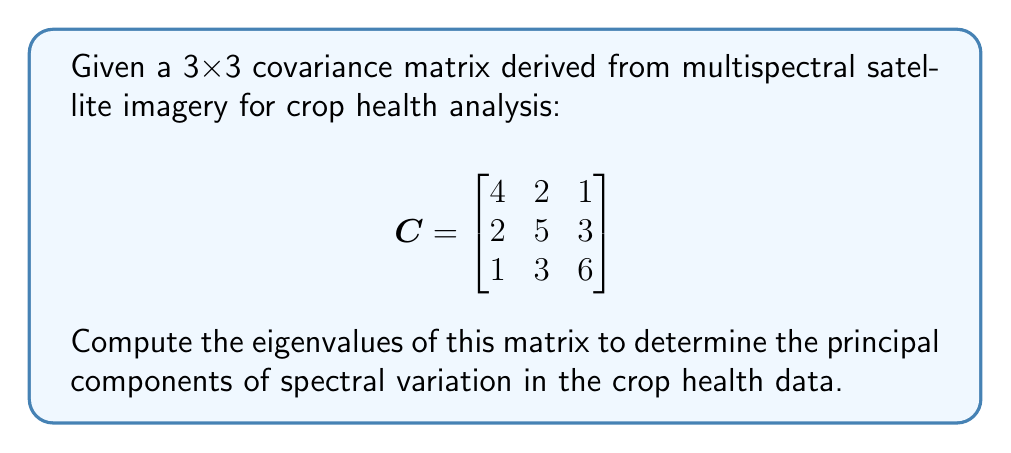Solve this math problem. To find the eigenvalues of the covariance matrix C, we need to solve the characteristic equation:

$$\det(C - \lambda I) = 0$$

Where $I$ is the 3x3 identity matrix and $\lambda$ represents the eigenvalues.

Step 1: Set up the characteristic equation:
$$\det\begin{bmatrix}
4-\lambda & 2 & 1 \\
2 & 5-\lambda & 3 \\
1 & 3 & 6-\lambda
\end{bmatrix} = 0$$

Step 2: Expand the determinant:
$$(4-\lambda)[(5-\lambda)(6-\lambda)-9] - 2[2(6-\lambda)-3] + 1[2\cdot3-(5-\lambda)] = 0$$

Step 3: Simplify:
$$(4-\lambda)[(30-11\lambda+\lambda^2)-9] - 2[12-2\lambda-3] + [6-(5-\lambda)] = 0$$
$$(4-\lambda)(21-11\lambda+\lambda^2) - 2(9-2\lambda) + (\lambda+1) = 0$$

Step 4: Expand and collect terms:
$$84-44\lambda+4\lambda^2-21\lambda+11\lambda^2-\lambda^3-18+4\lambda+\lambda+1 = 0$$
$$-\lambda^3+15\lambda^2-61\lambda+67 = 0$$

Step 5: Solve the cubic equation. This can be done using the cubic formula or numerical methods. The roots of this equation are the eigenvalues:

$\lambda_1 \approx 8.90$
$\lambda_2 \approx 4.76$
$\lambda_3 \approx 1.34$

These eigenvalues represent the variances along the principal component axes of the spectral data, with the largest eigenvalue corresponding to the direction of greatest variation in crop health indicators.
Answer: $\lambda_1 \approx 8.90, \lambda_2 \approx 4.76, \lambda_3 \approx 1.34$ 